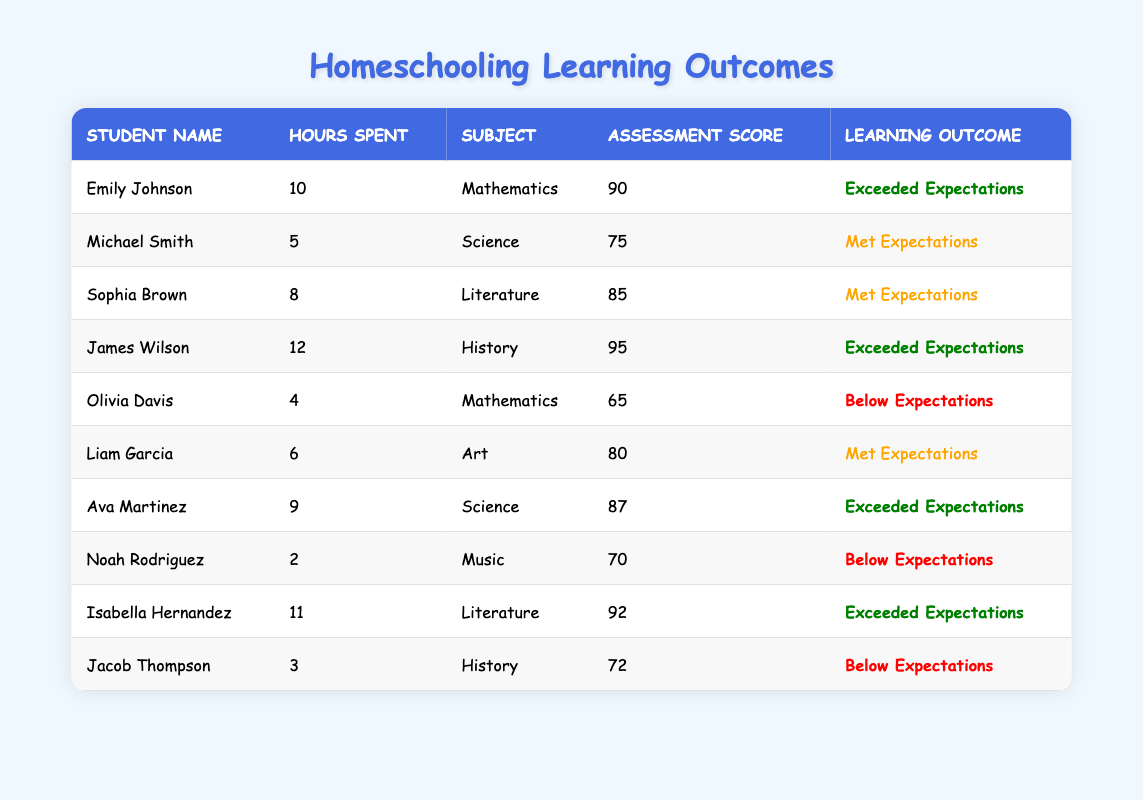What is the highest assessment score reported in the table? To find the highest assessment score, we look through the scores listed in the "Assessment Score" column. The highest score appears to be 95, which belongs to James Wilson in History.
Answer: 95 How many students exceeded expectations in their learning outcomes? By counting the rows where the "Learning Outcome" column is marked as "Exceeded Expectations," we identify four students: Emily Johnson, James Wilson, Ava Martinez, and Isabella Hernandez.
Answer: 4 What is the average number of hours spent on educational activities by all students? First, we add the hours spent: 10 + 5 + 8 + 12 + 4 + 6 + 9 + 2 + 11 + 3 = 70. There are 10 students, so we divide the total by 10: 70 / 10 = 7.
Answer: 7 Did any student score below expectations while spending 6 or more hours on educational activities? We check the "Hours Spent on Educational Activities" column for 6 or more hours and find Liam Garcia (6 hours, Met Expectations) and Olivia Davis (4 hours, Below Expectations). Since Olivia Davis does not meet the time criterion, the answer is no as there are no relevant students.
Answer: No Which subject had the most students who met or exceeded expectations? We analyze each subject: Mathematics (2), Science (2), Literature (2), Art (1), History (1), and Music (0). Subjects with met/exceeded expectations are Mathematics, Science, and Literature—each has 2 students meeting the criteria. Thus, there is a tie between these subjects.
Answer: Mathematics, Science, Literature (tie) How many students scored a 70 or above in their assessments? We will count students with scores listed as 70 or more: Emily Johnson (90), Michael Smith (75), Sophia Brown (85), James Wilson (95), Liam Garcia (80), Ava Martinez (87), Isabella Hernandez (92). There are 7 students.
Answer: 7 Is there a student who spent the least time on educational activities and scored above expectations? Upon reviewing the data, Noah Rodriguez spent 2 hours and scored 70, which is below expectations. The only student who spent less time than others and still scored above expectations is none; hence the answer is no.
Answer: No What subject did Emily Johnson study, and what was her learning outcome? Checking the data, Emily Johnson studied Mathematics and her learning outcome was "Exceeded Expectations."
Answer: Mathematics, Exceeded Expectations What is the relationship between hours spent and assessment scores in the data? By analyzing hours spent and corresponding scores, we notice that students who spent more hours (above 6) generally scored higher, while students spending less (like Noah Rodriguez and Olivia Davis) scored lower. It suggests a positive correlation, but additional data would be needed for a definitive conclusion.
Answer: Positive correlation observed 